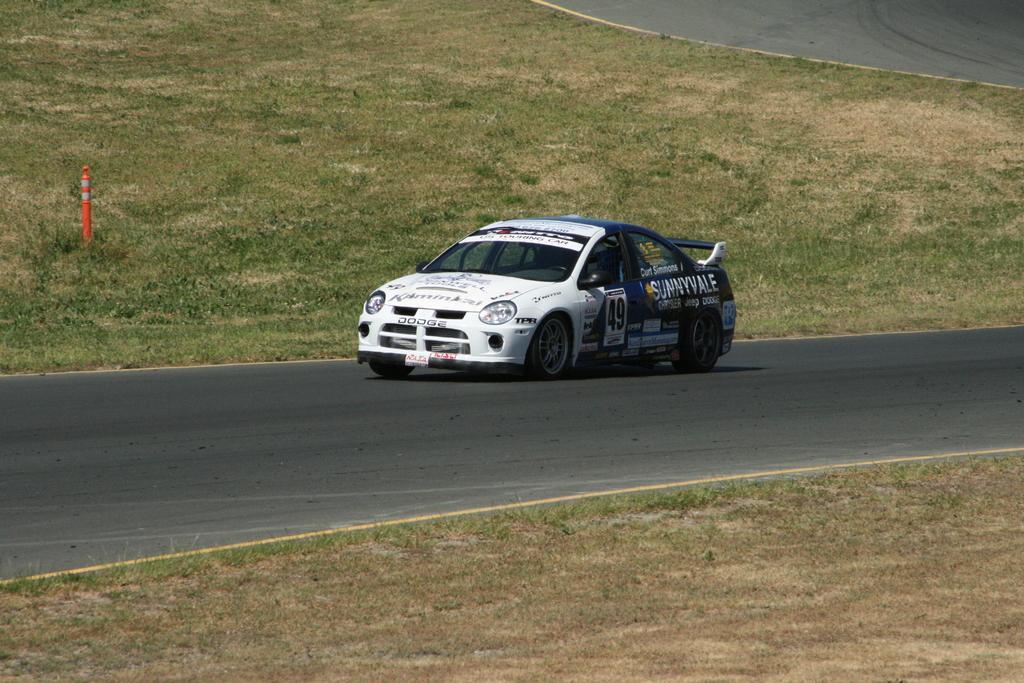Please provide a concise description of this image. This image consists of a car in white and blue color. At the bottom, there is a road and green grass. 